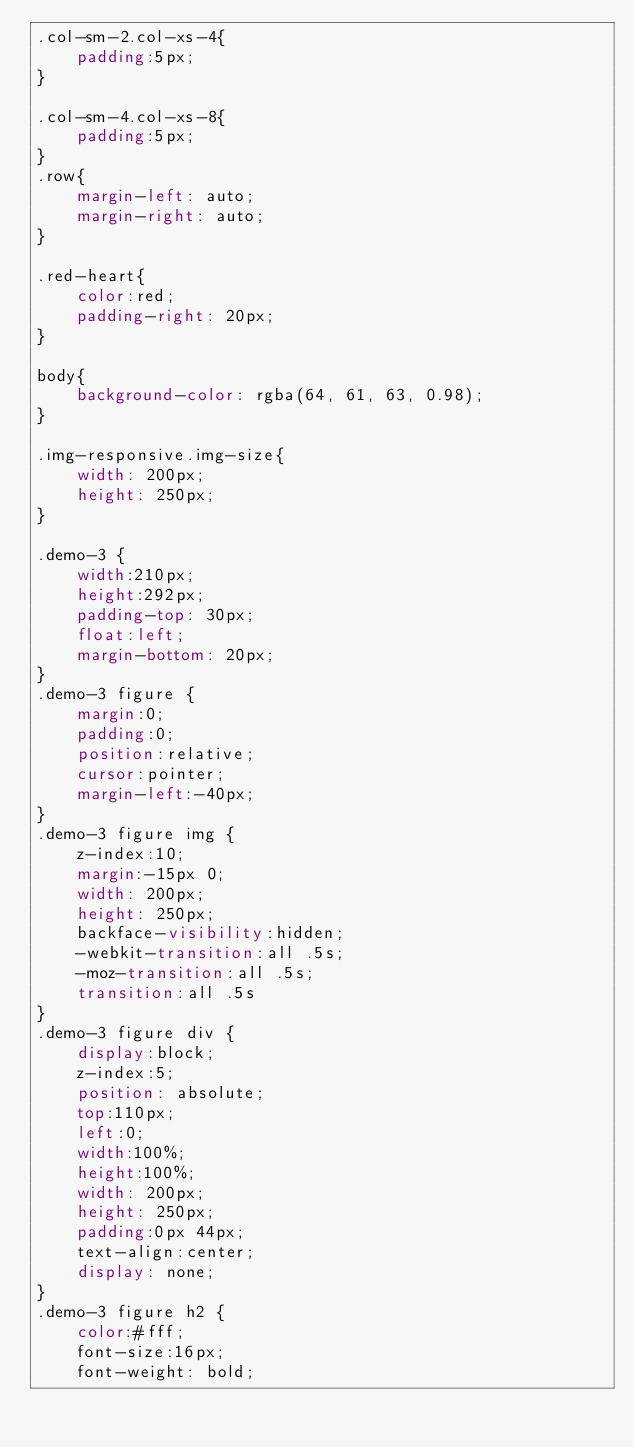<code> <loc_0><loc_0><loc_500><loc_500><_CSS_>.col-sm-2.col-xs-4{
    padding:5px;
}

.col-sm-4.col-xs-8{
    padding:5px;
}
.row{
    margin-left: auto;
    margin-right: auto;
}

.red-heart{
    color:red;
    padding-right: 20px;
}

body{
    background-color: rgba(64, 61, 63, 0.98);
}

.img-responsive.img-size{
    width: 200px;
    height: 250px;
}

.demo-3 {
    width:210px;
    height:292px;
    padding-top: 30px;
    float:left;
    margin-bottom: 20px;
}
.demo-3 figure {
    margin:0;
    padding:0;
    position:relative;
    cursor:pointer;
    margin-left:-40px;
}
.demo-3 figure img {
    z-index:10;
    margin:-15px 0;
    width: 200px;
    height: 250px;
    backface-visibility:hidden;
    -webkit-transition:all .5s;
    -moz-transition:all .5s;
    transition:all .5s
}
.demo-3 figure div {
    display:block;
    z-index:5;
    position: absolute;
    top:110px;
    left:0;
    width:100%;
    height:100%;
    width: 200px;
    height: 250px;
    padding:0px 44px;
    text-align:center;
    display: none;
}
.demo-3 figure h2 {
    color:#fff;
    font-size:16px;
    font-weight: bold;</code> 